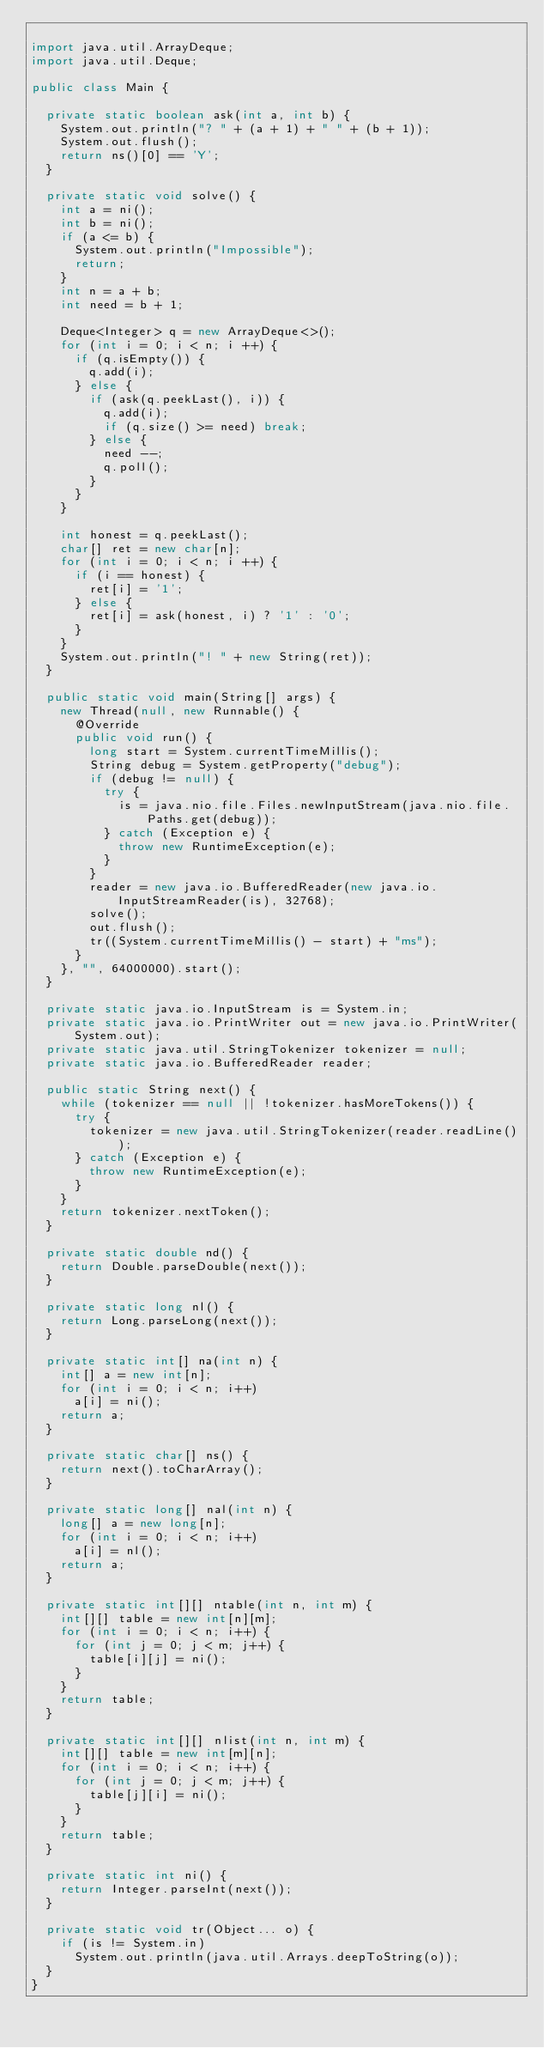Convert code to text. <code><loc_0><loc_0><loc_500><loc_500><_Java_>
import java.util.ArrayDeque;
import java.util.Deque;

public class Main {

  private static boolean ask(int a, int b) {
    System.out.println("? " + (a + 1) + " " + (b + 1));
    System.out.flush();
    return ns()[0] == 'Y';
  }

  private static void solve() {
    int a = ni();
    int b = ni();
    if (a <= b) {
      System.out.println("Impossible");
      return;
    }
    int n = a + b;
    int need = b + 1;

    Deque<Integer> q = new ArrayDeque<>();
    for (int i = 0; i < n; i ++) {
      if (q.isEmpty()) {
        q.add(i);
      } else {
        if (ask(q.peekLast(), i)) {
          q.add(i);
          if (q.size() >= need) break;
        } else {
          need --;
          q.poll();
        }
      }
    }
    
    int honest = q.peekLast();
    char[] ret = new char[n];
    for (int i = 0; i < n; i ++) {
      if (i == honest) {
        ret[i] = '1';
      } else {
        ret[i] = ask(honest, i) ? '1' : '0';
      }
    }
    System.out.println("! " + new String(ret));
  }

  public static void main(String[] args) {
    new Thread(null, new Runnable() {
      @Override
      public void run() {
        long start = System.currentTimeMillis();
        String debug = System.getProperty("debug");
        if (debug != null) {
          try {
            is = java.nio.file.Files.newInputStream(java.nio.file.Paths.get(debug));
          } catch (Exception e) {
            throw new RuntimeException(e);
          }
        }
        reader = new java.io.BufferedReader(new java.io.InputStreamReader(is), 32768);
        solve();
        out.flush();
        tr((System.currentTimeMillis() - start) + "ms");
      }
    }, "", 64000000).start();
  }

  private static java.io.InputStream is = System.in;
  private static java.io.PrintWriter out = new java.io.PrintWriter(System.out);
  private static java.util.StringTokenizer tokenizer = null;
  private static java.io.BufferedReader reader;

  public static String next() {
    while (tokenizer == null || !tokenizer.hasMoreTokens()) {
      try {
        tokenizer = new java.util.StringTokenizer(reader.readLine());
      } catch (Exception e) {
        throw new RuntimeException(e);
      }
    }
    return tokenizer.nextToken();
  }

  private static double nd() {
    return Double.parseDouble(next());
  }

  private static long nl() {
    return Long.parseLong(next());
  }

  private static int[] na(int n) {
    int[] a = new int[n];
    for (int i = 0; i < n; i++)
      a[i] = ni();
    return a;
  }

  private static char[] ns() {
    return next().toCharArray();
  }

  private static long[] nal(int n) {
    long[] a = new long[n];
    for (int i = 0; i < n; i++)
      a[i] = nl();
    return a;
  }

  private static int[][] ntable(int n, int m) {
    int[][] table = new int[n][m];
    for (int i = 0; i < n; i++) {
      for (int j = 0; j < m; j++) {
        table[i][j] = ni();
      }
    }
    return table;
  }

  private static int[][] nlist(int n, int m) {
    int[][] table = new int[m][n];
    for (int i = 0; i < n; i++) {
      for (int j = 0; j < m; j++) {
        table[j][i] = ni();
      }
    }
    return table;
  }

  private static int ni() {
    return Integer.parseInt(next());
  }

  private static void tr(Object... o) {
    if (is != System.in)
      System.out.println(java.util.Arrays.deepToString(o));
  }
}
</code> 